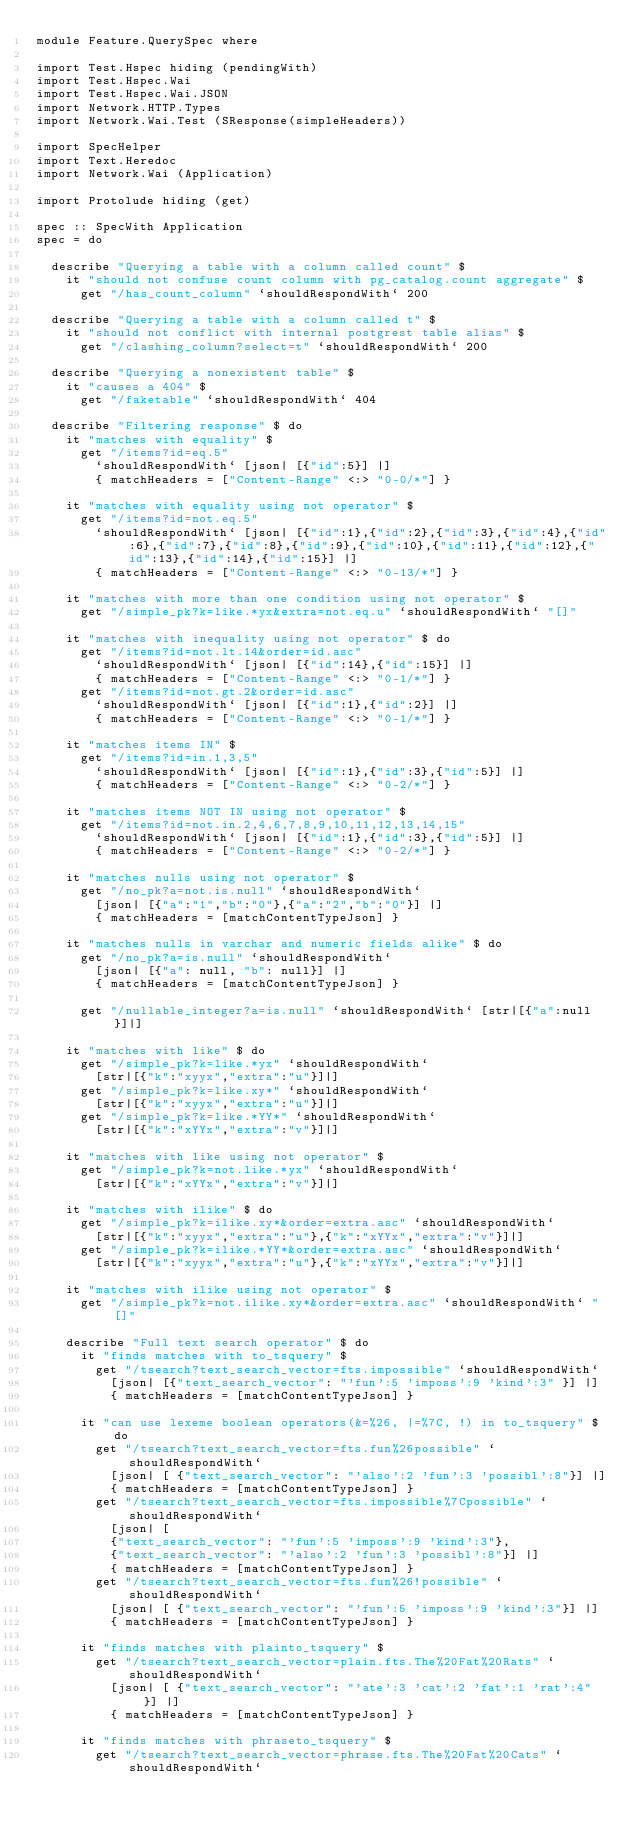Convert code to text. <code><loc_0><loc_0><loc_500><loc_500><_Haskell_>module Feature.QuerySpec where

import Test.Hspec hiding (pendingWith)
import Test.Hspec.Wai
import Test.Hspec.Wai.JSON
import Network.HTTP.Types
import Network.Wai.Test (SResponse(simpleHeaders))

import SpecHelper
import Text.Heredoc
import Network.Wai (Application)

import Protolude hiding (get)

spec :: SpecWith Application
spec = do

  describe "Querying a table with a column called count" $
    it "should not confuse count column with pg_catalog.count aggregate" $
      get "/has_count_column" `shouldRespondWith` 200

  describe "Querying a table with a column called t" $
    it "should not conflict with internal postgrest table alias" $
      get "/clashing_column?select=t" `shouldRespondWith` 200

  describe "Querying a nonexistent table" $
    it "causes a 404" $
      get "/faketable" `shouldRespondWith` 404

  describe "Filtering response" $ do
    it "matches with equality" $
      get "/items?id=eq.5"
        `shouldRespondWith` [json| [{"id":5}] |]
        { matchHeaders = ["Content-Range" <:> "0-0/*"] }

    it "matches with equality using not operator" $
      get "/items?id=not.eq.5"
        `shouldRespondWith` [json| [{"id":1},{"id":2},{"id":3},{"id":4},{"id":6},{"id":7},{"id":8},{"id":9},{"id":10},{"id":11},{"id":12},{"id":13},{"id":14},{"id":15}] |]
        { matchHeaders = ["Content-Range" <:> "0-13/*"] }

    it "matches with more than one condition using not operator" $
      get "/simple_pk?k=like.*yx&extra=not.eq.u" `shouldRespondWith` "[]"

    it "matches with inequality using not operator" $ do
      get "/items?id=not.lt.14&order=id.asc"
        `shouldRespondWith` [json| [{"id":14},{"id":15}] |]
        { matchHeaders = ["Content-Range" <:> "0-1/*"] }
      get "/items?id=not.gt.2&order=id.asc"
        `shouldRespondWith` [json| [{"id":1},{"id":2}] |]
        { matchHeaders = ["Content-Range" <:> "0-1/*"] }

    it "matches items IN" $
      get "/items?id=in.1,3,5"
        `shouldRespondWith` [json| [{"id":1},{"id":3},{"id":5}] |]
        { matchHeaders = ["Content-Range" <:> "0-2/*"] }

    it "matches items NOT IN using not operator" $
      get "/items?id=not.in.2,4,6,7,8,9,10,11,12,13,14,15"
        `shouldRespondWith` [json| [{"id":1},{"id":3},{"id":5}] |]
        { matchHeaders = ["Content-Range" <:> "0-2/*"] }

    it "matches nulls using not operator" $
      get "/no_pk?a=not.is.null" `shouldRespondWith`
        [json| [{"a":"1","b":"0"},{"a":"2","b":"0"}] |]
        { matchHeaders = [matchContentTypeJson] }

    it "matches nulls in varchar and numeric fields alike" $ do
      get "/no_pk?a=is.null" `shouldRespondWith`
        [json| [{"a": null, "b": null}] |]
        { matchHeaders = [matchContentTypeJson] }

      get "/nullable_integer?a=is.null" `shouldRespondWith` [str|[{"a":null}]|]

    it "matches with like" $ do
      get "/simple_pk?k=like.*yx" `shouldRespondWith`
        [str|[{"k":"xyyx","extra":"u"}]|]
      get "/simple_pk?k=like.xy*" `shouldRespondWith`
        [str|[{"k":"xyyx","extra":"u"}]|]
      get "/simple_pk?k=like.*YY*" `shouldRespondWith`
        [str|[{"k":"xYYx","extra":"v"}]|]

    it "matches with like using not operator" $
      get "/simple_pk?k=not.like.*yx" `shouldRespondWith`
        [str|[{"k":"xYYx","extra":"v"}]|]

    it "matches with ilike" $ do
      get "/simple_pk?k=ilike.xy*&order=extra.asc" `shouldRespondWith`
        [str|[{"k":"xyyx","extra":"u"},{"k":"xYYx","extra":"v"}]|]
      get "/simple_pk?k=ilike.*YY*&order=extra.asc" `shouldRespondWith`
        [str|[{"k":"xyyx","extra":"u"},{"k":"xYYx","extra":"v"}]|]

    it "matches with ilike using not operator" $
      get "/simple_pk?k=not.ilike.xy*&order=extra.asc" `shouldRespondWith` "[]"

    describe "Full text search operator" $ do
      it "finds matches with to_tsquery" $
        get "/tsearch?text_search_vector=fts.impossible" `shouldRespondWith`
          [json| [{"text_search_vector": "'fun':5 'imposs':9 'kind':3" }] |]
          { matchHeaders = [matchContentTypeJson] }

      it "can use lexeme boolean operators(&=%26, |=%7C, !) in to_tsquery" $ do
        get "/tsearch?text_search_vector=fts.fun%26possible" `shouldRespondWith`
          [json| [ {"text_search_vector": "'also':2 'fun':3 'possibl':8"}] |]
          { matchHeaders = [matchContentTypeJson] }
        get "/tsearch?text_search_vector=fts.impossible%7Cpossible" `shouldRespondWith`
          [json| [
          {"text_search_vector": "'fun':5 'imposs':9 'kind':3"},
          {"text_search_vector": "'also':2 'fun':3 'possibl':8"}] |]
          { matchHeaders = [matchContentTypeJson] }
        get "/tsearch?text_search_vector=fts.fun%26!possible" `shouldRespondWith`
          [json| [ {"text_search_vector": "'fun':5 'imposs':9 'kind':3"}] |]
          { matchHeaders = [matchContentTypeJson] }

      it "finds matches with plainto_tsquery" $
        get "/tsearch?text_search_vector=plain.fts.The%20Fat%20Rats" `shouldRespondWith`
          [json| [ {"text_search_vector": "'ate':3 'cat':2 'fat':1 'rat':4" }] |]
          { matchHeaders = [matchContentTypeJson] }

      it "finds matches with phraseto_tsquery" $
        get "/tsearch?text_search_vector=phrase.fts.The%20Fat%20Cats" `shouldRespondWith`</code> 